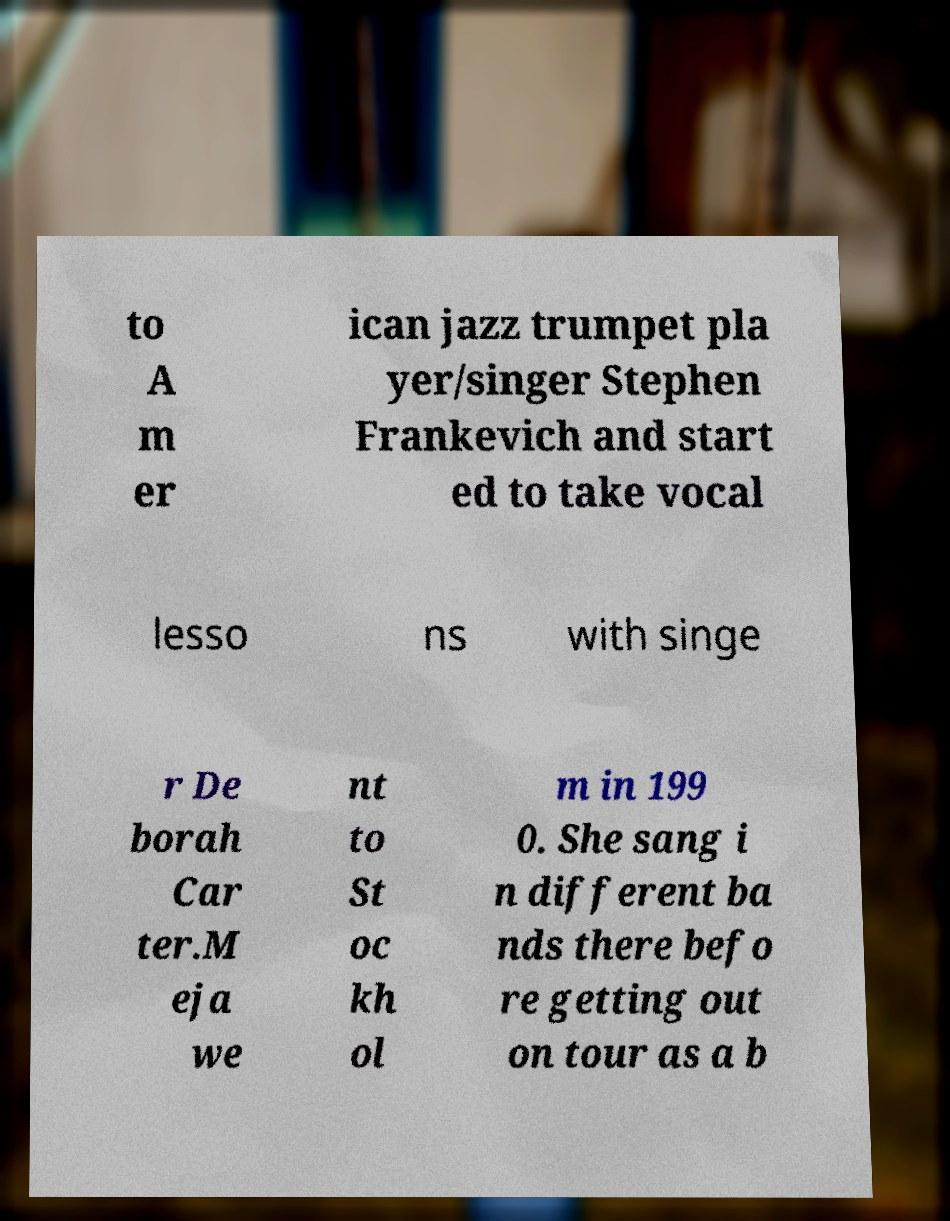Can you accurately transcribe the text from the provided image for me? to A m er ican jazz trumpet pla yer/singer Stephen Frankevich and start ed to take vocal lesso ns with singe r De borah Car ter.M eja we nt to St oc kh ol m in 199 0. She sang i n different ba nds there befo re getting out on tour as a b 